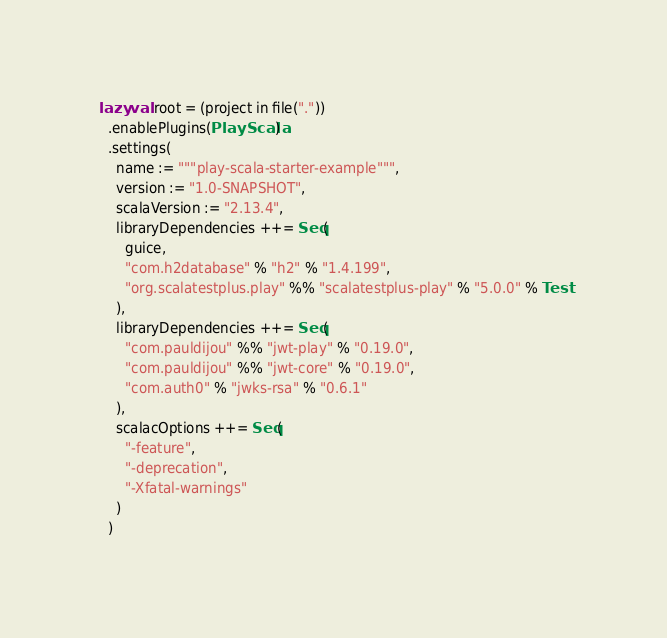Convert code to text. <code><loc_0><loc_0><loc_500><loc_500><_Scala_>lazy val root = (project in file("."))
  .enablePlugins(PlayScala)
  .settings(
    name := """play-scala-starter-example""",
    version := "1.0-SNAPSHOT",
    scalaVersion := "2.13.4",
    libraryDependencies ++= Seq(
      guice,
      "com.h2database" % "h2" % "1.4.199",
      "org.scalatestplus.play" %% "scalatestplus-play" % "5.0.0" % Test
    ),
    libraryDependencies ++= Seq(
      "com.pauldijou" %% "jwt-play" % "0.19.0",
      "com.pauldijou" %% "jwt-core" % "0.19.0",
      "com.auth0" % "jwks-rsa" % "0.6.1"
    ),
    scalacOptions ++= Seq(
      "-feature",
      "-deprecation",
      "-Xfatal-warnings"
    )
  )
</code> 